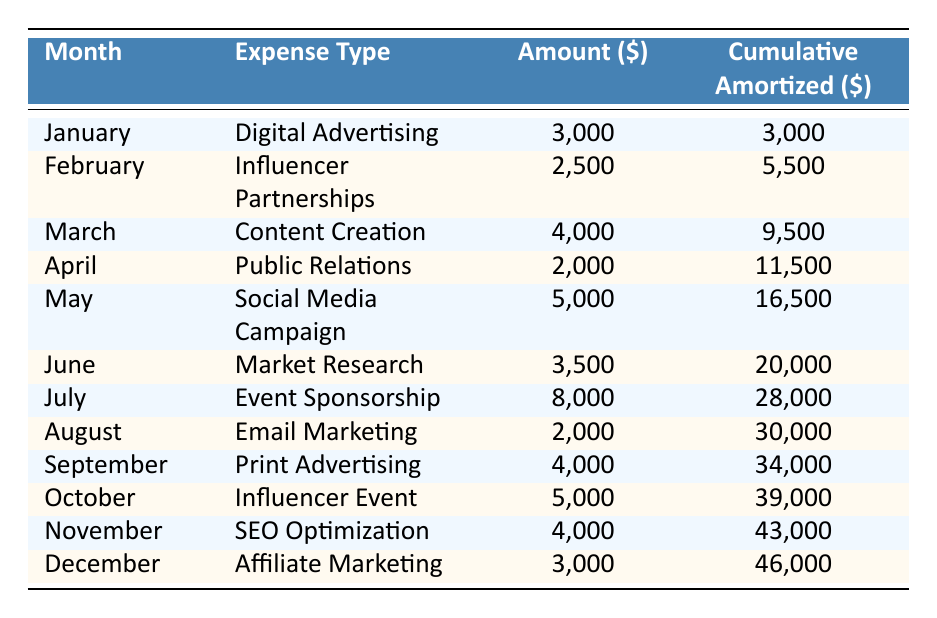What was the highest monthly marketing expense in 2023? By looking at the table, the highest amount listed is for July, which is 8,000 dollars for Event Sponsorship.
Answer: 8,000 What is the cumulative amortized amount after June? The cumulative amortized amount for June is directly stated in the table as 20,000 dollars.
Answer: 20,000 Did we spend more on Influencer Partnerships or Affiliate Marketing? The table shows that Influencer Partnerships cost 2,500 dollars and Affiliate Marketing cost 3,000 dollars. Since 3,000 is greater than 2,500, we spent more on Affiliate Marketing.
Answer: Yes What is the total amount spent on Digital Advertising and SEO Optimization combined? The amount for Digital Advertising is 3,000 dollars and for SEO Optimization, it's 4,000 dollars. Adding these amounts together gives 3,000 + 4,000 = 7,000 dollars.
Answer: 7,000 What was the cumulative amortized amount at the end of the product launch year? The cumulative amortized amount at the end of December is 46,000 dollars, as stated in the last row of the table.
Answer: 46,000 Was the monthly amortization consistently reached throughout the year? To determine this, we can check the monthly expenses. The total monthly amortization is stated as 10,000 dollars, and the total expenses at the end of the year equate to 120,000 dollars divided by 12 months equals 10,000 dollars per month. Since each month's amount adds up to exactly 10,000 dollars, yes, the amortization target was met.
Answer: Yes What is the average monthly expense for the marketing types listed? To find the average, we sum all monthly amounts: 3,000 + 2,500 + 4,000 + 2,000 + 5,000 + 3,500 + 8,000 + 2,000 + 4,000 + 5,000 + 4,000 + 3,000 = 46,000 dollars. There are 12 months, so the average is 46,000 divided by 12, which equals approximately 3,833.33 dollars.
Answer: About 3,833.33 How many months had an expense amount greater than 5,000 dollars? By reviewing the table, the months with amounts greater than 5,000 dollars are July (8,000 dollars) and May (5,000 dollars). This results in a total of 2 months.
Answer: 2 What was the total expense for Content Creation and Email Marketing? The expense for Content Creation is 4,000 dollars and for Email Marketing is 2,000 dollars. Adding these together: 4,000 + 2,000 = 6,000 dollars totals.
Answer: 6,000 